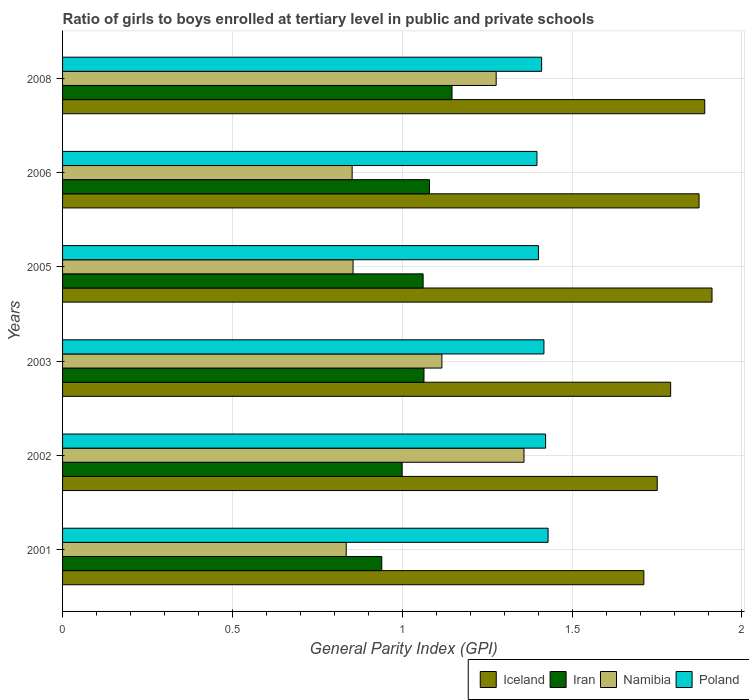How many bars are there on the 2nd tick from the top?
Provide a succinct answer. 4. In how many cases, is the number of bars for a given year not equal to the number of legend labels?
Make the answer very short. 0. What is the general parity index in Iceland in 2002?
Make the answer very short. 1.75. Across all years, what is the maximum general parity index in Poland?
Offer a terse response. 1.43. Across all years, what is the minimum general parity index in Poland?
Offer a very short reply. 1.4. What is the total general parity index in Iran in the graph?
Your answer should be compact. 6.29. What is the difference between the general parity index in Iceland in 2003 and that in 2005?
Your answer should be compact. -0.12. What is the difference between the general parity index in Poland in 2005 and the general parity index in Iceland in 2008?
Offer a very short reply. -0.49. What is the average general parity index in Iran per year?
Offer a very short reply. 1.05. In the year 2003, what is the difference between the general parity index in Iceland and general parity index in Poland?
Give a very brief answer. 0.37. In how many years, is the general parity index in Iceland greater than 1.5 ?
Your response must be concise. 6. What is the ratio of the general parity index in Iceland in 2001 to that in 2006?
Offer a very short reply. 0.91. Is the difference between the general parity index in Iceland in 2005 and 2006 greater than the difference between the general parity index in Poland in 2005 and 2006?
Your response must be concise. Yes. What is the difference between the highest and the second highest general parity index in Iceland?
Offer a very short reply. 0.02. What is the difference between the highest and the lowest general parity index in Poland?
Your response must be concise. 0.03. In how many years, is the general parity index in Iceland greater than the average general parity index in Iceland taken over all years?
Keep it short and to the point. 3. Is the sum of the general parity index in Iran in 2002 and 2005 greater than the maximum general parity index in Iceland across all years?
Provide a succinct answer. Yes. What does the 2nd bar from the top in 2001 represents?
Keep it short and to the point. Namibia. What does the 3rd bar from the bottom in 2002 represents?
Provide a succinct answer. Namibia. Is it the case that in every year, the sum of the general parity index in Iceland and general parity index in Namibia is greater than the general parity index in Poland?
Offer a very short reply. Yes. Are all the bars in the graph horizontal?
Give a very brief answer. Yes. How many years are there in the graph?
Your answer should be very brief. 6. What is the difference between two consecutive major ticks on the X-axis?
Provide a short and direct response. 0.5. Are the values on the major ticks of X-axis written in scientific E-notation?
Provide a succinct answer. No. Does the graph contain grids?
Ensure brevity in your answer.  Yes. What is the title of the graph?
Offer a very short reply. Ratio of girls to boys enrolled at tertiary level in public and private schools. Does "Sint Maarten (Dutch part)" appear as one of the legend labels in the graph?
Offer a very short reply. No. What is the label or title of the X-axis?
Your answer should be very brief. General Parity Index (GPI). What is the label or title of the Y-axis?
Keep it short and to the point. Years. What is the General Parity Index (GPI) in Iceland in 2001?
Offer a terse response. 1.71. What is the General Parity Index (GPI) in Iran in 2001?
Your response must be concise. 0.94. What is the General Parity Index (GPI) of Namibia in 2001?
Ensure brevity in your answer.  0.83. What is the General Parity Index (GPI) in Poland in 2001?
Ensure brevity in your answer.  1.43. What is the General Parity Index (GPI) of Iceland in 2002?
Ensure brevity in your answer.  1.75. What is the General Parity Index (GPI) of Iran in 2002?
Offer a terse response. 1. What is the General Parity Index (GPI) of Namibia in 2002?
Your answer should be very brief. 1.36. What is the General Parity Index (GPI) in Poland in 2002?
Give a very brief answer. 1.42. What is the General Parity Index (GPI) in Iceland in 2003?
Your answer should be compact. 1.79. What is the General Parity Index (GPI) of Iran in 2003?
Your answer should be very brief. 1.06. What is the General Parity Index (GPI) of Namibia in 2003?
Ensure brevity in your answer.  1.12. What is the General Parity Index (GPI) in Poland in 2003?
Provide a succinct answer. 1.42. What is the General Parity Index (GPI) in Iceland in 2005?
Make the answer very short. 1.91. What is the General Parity Index (GPI) in Iran in 2005?
Keep it short and to the point. 1.06. What is the General Parity Index (GPI) of Namibia in 2005?
Give a very brief answer. 0.86. What is the General Parity Index (GPI) of Poland in 2005?
Offer a terse response. 1.4. What is the General Parity Index (GPI) of Iceland in 2006?
Offer a terse response. 1.87. What is the General Parity Index (GPI) in Iran in 2006?
Provide a succinct answer. 1.08. What is the General Parity Index (GPI) in Namibia in 2006?
Make the answer very short. 0.85. What is the General Parity Index (GPI) of Poland in 2006?
Offer a very short reply. 1.4. What is the General Parity Index (GPI) in Iceland in 2008?
Ensure brevity in your answer.  1.89. What is the General Parity Index (GPI) of Iran in 2008?
Your answer should be compact. 1.15. What is the General Parity Index (GPI) of Namibia in 2008?
Provide a succinct answer. 1.28. What is the General Parity Index (GPI) of Poland in 2008?
Provide a short and direct response. 1.41. Across all years, what is the maximum General Parity Index (GPI) of Iceland?
Offer a terse response. 1.91. Across all years, what is the maximum General Parity Index (GPI) in Iran?
Give a very brief answer. 1.15. Across all years, what is the maximum General Parity Index (GPI) of Namibia?
Give a very brief answer. 1.36. Across all years, what is the maximum General Parity Index (GPI) in Poland?
Your answer should be compact. 1.43. Across all years, what is the minimum General Parity Index (GPI) in Iceland?
Keep it short and to the point. 1.71. Across all years, what is the minimum General Parity Index (GPI) in Iran?
Your answer should be compact. 0.94. Across all years, what is the minimum General Parity Index (GPI) in Namibia?
Keep it short and to the point. 0.83. Across all years, what is the minimum General Parity Index (GPI) in Poland?
Keep it short and to the point. 1.4. What is the total General Parity Index (GPI) in Iceland in the graph?
Ensure brevity in your answer.  10.93. What is the total General Parity Index (GPI) of Iran in the graph?
Your answer should be compact. 6.29. What is the total General Parity Index (GPI) in Namibia in the graph?
Keep it short and to the point. 6.29. What is the total General Parity Index (GPI) of Poland in the graph?
Your answer should be very brief. 8.48. What is the difference between the General Parity Index (GPI) of Iceland in 2001 and that in 2002?
Give a very brief answer. -0.04. What is the difference between the General Parity Index (GPI) of Iran in 2001 and that in 2002?
Provide a succinct answer. -0.06. What is the difference between the General Parity Index (GPI) in Namibia in 2001 and that in 2002?
Your response must be concise. -0.52. What is the difference between the General Parity Index (GPI) in Poland in 2001 and that in 2002?
Ensure brevity in your answer.  0.01. What is the difference between the General Parity Index (GPI) of Iceland in 2001 and that in 2003?
Make the answer very short. -0.08. What is the difference between the General Parity Index (GPI) in Iran in 2001 and that in 2003?
Provide a short and direct response. -0.12. What is the difference between the General Parity Index (GPI) of Namibia in 2001 and that in 2003?
Offer a terse response. -0.28. What is the difference between the General Parity Index (GPI) in Poland in 2001 and that in 2003?
Your answer should be very brief. 0.01. What is the difference between the General Parity Index (GPI) in Iceland in 2001 and that in 2005?
Offer a very short reply. -0.2. What is the difference between the General Parity Index (GPI) of Iran in 2001 and that in 2005?
Your answer should be compact. -0.12. What is the difference between the General Parity Index (GPI) of Namibia in 2001 and that in 2005?
Your response must be concise. -0.02. What is the difference between the General Parity Index (GPI) in Poland in 2001 and that in 2005?
Your answer should be very brief. 0.03. What is the difference between the General Parity Index (GPI) of Iceland in 2001 and that in 2006?
Ensure brevity in your answer.  -0.16. What is the difference between the General Parity Index (GPI) of Iran in 2001 and that in 2006?
Your answer should be very brief. -0.14. What is the difference between the General Parity Index (GPI) in Namibia in 2001 and that in 2006?
Make the answer very short. -0.02. What is the difference between the General Parity Index (GPI) in Poland in 2001 and that in 2006?
Your response must be concise. 0.03. What is the difference between the General Parity Index (GPI) in Iceland in 2001 and that in 2008?
Offer a very short reply. -0.18. What is the difference between the General Parity Index (GPI) in Iran in 2001 and that in 2008?
Provide a succinct answer. -0.21. What is the difference between the General Parity Index (GPI) in Namibia in 2001 and that in 2008?
Provide a succinct answer. -0.44. What is the difference between the General Parity Index (GPI) in Poland in 2001 and that in 2008?
Keep it short and to the point. 0.02. What is the difference between the General Parity Index (GPI) in Iceland in 2002 and that in 2003?
Keep it short and to the point. -0.04. What is the difference between the General Parity Index (GPI) in Iran in 2002 and that in 2003?
Keep it short and to the point. -0.06. What is the difference between the General Parity Index (GPI) in Namibia in 2002 and that in 2003?
Make the answer very short. 0.24. What is the difference between the General Parity Index (GPI) in Poland in 2002 and that in 2003?
Offer a very short reply. 0. What is the difference between the General Parity Index (GPI) in Iceland in 2002 and that in 2005?
Offer a terse response. -0.16. What is the difference between the General Parity Index (GPI) in Iran in 2002 and that in 2005?
Keep it short and to the point. -0.06. What is the difference between the General Parity Index (GPI) in Namibia in 2002 and that in 2005?
Offer a very short reply. 0.5. What is the difference between the General Parity Index (GPI) of Poland in 2002 and that in 2005?
Your answer should be very brief. 0.02. What is the difference between the General Parity Index (GPI) of Iceland in 2002 and that in 2006?
Provide a succinct answer. -0.12. What is the difference between the General Parity Index (GPI) of Iran in 2002 and that in 2006?
Keep it short and to the point. -0.08. What is the difference between the General Parity Index (GPI) of Namibia in 2002 and that in 2006?
Give a very brief answer. 0.51. What is the difference between the General Parity Index (GPI) in Poland in 2002 and that in 2006?
Your response must be concise. 0.03. What is the difference between the General Parity Index (GPI) of Iceland in 2002 and that in 2008?
Ensure brevity in your answer.  -0.14. What is the difference between the General Parity Index (GPI) of Iran in 2002 and that in 2008?
Make the answer very short. -0.15. What is the difference between the General Parity Index (GPI) in Namibia in 2002 and that in 2008?
Keep it short and to the point. 0.08. What is the difference between the General Parity Index (GPI) of Poland in 2002 and that in 2008?
Offer a very short reply. 0.01. What is the difference between the General Parity Index (GPI) in Iceland in 2003 and that in 2005?
Make the answer very short. -0.12. What is the difference between the General Parity Index (GPI) of Iran in 2003 and that in 2005?
Your response must be concise. 0. What is the difference between the General Parity Index (GPI) in Namibia in 2003 and that in 2005?
Your answer should be very brief. 0.26. What is the difference between the General Parity Index (GPI) of Poland in 2003 and that in 2005?
Offer a very short reply. 0.02. What is the difference between the General Parity Index (GPI) of Iceland in 2003 and that in 2006?
Your answer should be very brief. -0.08. What is the difference between the General Parity Index (GPI) in Iran in 2003 and that in 2006?
Provide a succinct answer. -0.02. What is the difference between the General Parity Index (GPI) in Namibia in 2003 and that in 2006?
Give a very brief answer. 0.26. What is the difference between the General Parity Index (GPI) of Poland in 2003 and that in 2006?
Provide a short and direct response. 0.02. What is the difference between the General Parity Index (GPI) of Iceland in 2003 and that in 2008?
Your answer should be compact. -0.1. What is the difference between the General Parity Index (GPI) in Iran in 2003 and that in 2008?
Ensure brevity in your answer.  -0.08. What is the difference between the General Parity Index (GPI) in Namibia in 2003 and that in 2008?
Provide a short and direct response. -0.16. What is the difference between the General Parity Index (GPI) in Poland in 2003 and that in 2008?
Make the answer very short. 0.01. What is the difference between the General Parity Index (GPI) in Iceland in 2005 and that in 2006?
Provide a short and direct response. 0.04. What is the difference between the General Parity Index (GPI) in Iran in 2005 and that in 2006?
Offer a terse response. -0.02. What is the difference between the General Parity Index (GPI) of Namibia in 2005 and that in 2006?
Keep it short and to the point. 0. What is the difference between the General Parity Index (GPI) of Poland in 2005 and that in 2006?
Offer a very short reply. 0. What is the difference between the General Parity Index (GPI) of Iceland in 2005 and that in 2008?
Offer a very short reply. 0.02. What is the difference between the General Parity Index (GPI) of Iran in 2005 and that in 2008?
Make the answer very short. -0.09. What is the difference between the General Parity Index (GPI) in Namibia in 2005 and that in 2008?
Provide a succinct answer. -0.42. What is the difference between the General Parity Index (GPI) in Poland in 2005 and that in 2008?
Offer a very short reply. -0.01. What is the difference between the General Parity Index (GPI) of Iceland in 2006 and that in 2008?
Offer a terse response. -0.02. What is the difference between the General Parity Index (GPI) in Iran in 2006 and that in 2008?
Offer a terse response. -0.07. What is the difference between the General Parity Index (GPI) in Namibia in 2006 and that in 2008?
Provide a succinct answer. -0.42. What is the difference between the General Parity Index (GPI) of Poland in 2006 and that in 2008?
Your answer should be compact. -0.01. What is the difference between the General Parity Index (GPI) of Iceland in 2001 and the General Parity Index (GPI) of Iran in 2002?
Provide a succinct answer. 0.71. What is the difference between the General Parity Index (GPI) of Iceland in 2001 and the General Parity Index (GPI) of Namibia in 2002?
Give a very brief answer. 0.35. What is the difference between the General Parity Index (GPI) in Iceland in 2001 and the General Parity Index (GPI) in Poland in 2002?
Your answer should be very brief. 0.29. What is the difference between the General Parity Index (GPI) of Iran in 2001 and the General Parity Index (GPI) of Namibia in 2002?
Make the answer very short. -0.42. What is the difference between the General Parity Index (GPI) of Iran in 2001 and the General Parity Index (GPI) of Poland in 2002?
Your response must be concise. -0.48. What is the difference between the General Parity Index (GPI) of Namibia in 2001 and the General Parity Index (GPI) of Poland in 2002?
Provide a succinct answer. -0.59. What is the difference between the General Parity Index (GPI) of Iceland in 2001 and the General Parity Index (GPI) of Iran in 2003?
Make the answer very short. 0.65. What is the difference between the General Parity Index (GPI) of Iceland in 2001 and the General Parity Index (GPI) of Namibia in 2003?
Provide a succinct answer. 0.59. What is the difference between the General Parity Index (GPI) in Iceland in 2001 and the General Parity Index (GPI) in Poland in 2003?
Your answer should be very brief. 0.29. What is the difference between the General Parity Index (GPI) in Iran in 2001 and the General Parity Index (GPI) in Namibia in 2003?
Make the answer very short. -0.18. What is the difference between the General Parity Index (GPI) of Iran in 2001 and the General Parity Index (GPI) of Poland in 2003?
Offer a terse response. -0.48. What is the difference between the General Parity Index (GPI) of Namibia in 2001 and the General Parity Index (GPI) of Poland in 2003?
Your answer should be compact. -0.58. What is the difference between the General Parity Index (GPI) in Iceland in 2001 and the General Parity Index (GPI) in Iran in 2005?
Provide a succinct answer. 0.65. What is the difference between the General Parity Index (GPI) of Iceland in 2001 and the General Parity Index (GPI) of Namibia in 2005?
Ensure brevity in your answer.  0.86. What is the difference between the General Parity Index (GPI) of Iceland in 2001 and the General Parity Index (GPI) of Poland in 2005?
Keep it short and to the point. 0.31. What is the difference between the General Parity Index (GPI) of Iran in 2001 and the General Parity Index (GPI) of Namibia in 2005?
Provide a short and direct response. 0.08. What is the difference between the General Parity Index (GPI) of Iran in 2001 and the General Parity Index (GPI) of Poland in 2005?
Provide a succinct answer. -0.46. What is the difference between the General Parity Index (GPI) of Namibia in 2001 and the General Parity Index (GPI) of Poland in 2005?
Offer a terse response. -0.57. What is the difference between the General Parity Index (GPI) in Iceland in 2001 and the General Parity Index (GPI) in Iran in 2006?
Offer a very short reply. 0.63. What is the difference between the General Parity Index (GPI) of Iceland in 2001 and the General Parity Index (GPI) of Namibia in 2006?
Keep it short and to the point. 0.86. What is the difference between the General Parity Index (GPI) of Iceland in 2001 and the General Parity Index (GPI) of Poland in 2006?
Your response must be concise. 0.31. What is the difference between the General Parity Index (GPI) in Iran in 2001 and the General Parity Index (GPI) in Namibia in 2006?
Provide a succinct answer. 0.09. What is the difference between the General Parity Index (GPI) of Iran in 2001 and the General Parity Index (GPI) of Poland in 2006?
Your answer should be very brief. -0.46. What is the difference between the General Parity Index (GPI) of Namibia in 2001 and the General Parity Index (GPI) of Poland in 2006?
Offer a very short reply. -0.56. What is the difference between the General Parity Index (GPI) of Iceland in 2001 and the General Parity Index (GPI) of Iran in 2008?
Provide a succinct answer. 0.56. What is the difference between the General Parity Index (GPI) of Iceland in 2001 and the General Parity Index (GPI) of Namibia in 2008?
Ensure brevity in your answer.  0.43. What is the difference between the General Parity Index (GPI) in Iceland in 2001 and the General Parity Index (GPI) in Poland in 2008?
Your answer should be compact. 0.3. What is the difference between the General Parity Index (GPI) in Iran in 2001 and the General Parity Index (GPI) in Namibia in 2008?
Provide a short and direct response. -0.34. What is the difference between the General Parity Index (GPI) in Iran in 2001 and the General Parity Index (GPI) in Poland in 2008?
Keep it short and to the point. -0.47. What is the difference between the General Parity Index (GPI) of Namibia in 2001 and the General Parity Index (GPI) of Poland in 2008?
Your response must be concise. -0.58. What is the difference between the General Parity Index (GPI) in Iceland in 2002 and the General Parity Index (GPI) in Iran in 2003?
Give a very brief answer. 0.69. What is the difference between the General Parity Index (GPI) of Iceland in 2002 and the General Parity Index (GPI) of Namibia in 2003?
Provide a succinct answer. 0.63. What is the difference between the General Parity Index (GPI) in Iceland in 2002 and the General Parity Index (GPI) in Poland in 2003?
Give a very brief answer. 0.33. What is the difference between the General Parity Index (GPI) of Iran in 2002 and the General Parity Index (GPI) of Namibia in 2003?
Offer a very short reply. -0.12. What is the difference between the General Parity Index (GPI) of Iran in 2002 and the General Parity Index (GPI) of Poland in 2003?
Give a very brief answer. -0.42. What is the difference between the General Parity Index (GPI) in Namibia in 2002 and the General Parity Index (GPI) in Poland in 2003?
Your answer should be very brief. -0.06. What is the difference between the General Parity Index (GPI) in Iceland in 2002 and the General Parity Index (GPI) in Iran in 2005?
Offer a very short reply. 0.69. What is the difference between the General Parity Index (GPI) of Iceland in 2002 and the General Parity Index (GPI) of Namibia in 2005?
Keep it short and to the point. 0.9. What is the difference between the General Parity Index (GPI) in Iceland in 2002 and the General Parity Index (GPI) in Poland in 2005?
Offer a terse response. 0.35. What is the difference between the General Parity Index (GPI) of Iran in 2002 and the General Parity Index (GPI) of Namibia in 2005?
Offer a very short reply. 0.14. What is the difference between the General Parity Index (GPI) of Iran in 2002 and the General Parity Index (GPI) of Poland in 2005?
Give a very brief answer. -0.4. What is the difference between the General Parity Index (GPI) of Namibia in 2002 and the General Parity Index (GPI) of Poland in 2005?
Ensure brevity in your answer.  -0.04. What is the difference between the General Parity Index (GPI) in Iceland in 2002 and the General Parity Index (GPI) in Iran in 2006?
Your answer should be compact. 0.67. What is the difference between the General Parity Index (GPI) in Iceland in 2002 and the General Parity Index (GPI) in Namibia in 2006?
Offer a very short reply. 0.9. What is the difference between the General Parity Index (GPI) in Iceland in 2002 and the General Parity Index (GPI) in Poland in 2006?
Make the answer very short. 0.35. What is the difference between the General Parity Index (GPI) in Iran in 2002 and the General Parity Index (GPI) in Namibia in 2006?
Offer a very short reply. 0.15. What is the difference between the General Parity Index (GPI) in Iran in 2002 and the General Parity Index (GPI) in Poland in 2006?
Your answer should be compact. -0.4. What is the difference between the General Parity Index (GPI) of Namibia in 2002 and the General Parity Index (GPI) of Poland in 2006?
Make the answer very short. -0.04. What is the difference between the General Parity Index (GPI) in Iceland in 2002 and the General Parity Index (GPI) in Iran in 2008?
Offer a terse response. 0.6. What is the difference between the General Parity Index (GPI) in Iceland in 2002 and the General Parity Index (GPI) in Namibia in 2008?
Your answer should be compact. 0.47. What is the difference between the General Parity Index (GPI) of Iceland in 2002 and the General Parity Index (GPI) of Poland in 2008?
Provide a short and direct response. 0.34. What is the difference between the General Parity Index (GPI) in Iran in 2002 and the General Parity Index (GPI) in Namibia in 2008?
Make the answer very short. -0.28. What is the difference between the General Parity Index (GPI) of Iran in 2002 and the General Parity Index (GPI) of Poland in 2008?
Give a very brief answer. -0.41. What is the difference between the General Parity Index (GPI) of Namibia in 2002 and the General Parity Index (GPI) of Poland in 2008?
Give a very brief answer. -0.05. What is the difference between the General Parity Index (GPI) of Iceland in 2003 and the General Parity Index (GPI) of Iran in 2005?
Give a very brief answer. 0.73. What is the difference between the General Parity Index (GPI) in Iceland in 2003 and the General Parity Index (GPI) in Namibia in 2005?
Offer a terse response. 0.93. What is the difference between the General Parity Index (GPI) in Iceland in 2003 and the General Parity Index (GPI) in Poland in 2005?
Your response must be concise. 0.39. What is the difference between the General Parity Index (GPI) in Iran in 2003 and the General Parity Index (GPI) in Namibia in 2005?
Make the answer very short. 0.21. What is the difference between the General Parity Index (GPI) in Iran in 2003 and the General Parity Index (GPI) in Poland in 2005?
Make the answer very short. -0.34. What is the difference between the General Parity Index (GPI) of Namibia in 2003 and the General Parity Index (GPI) of Poland in 2005?
Your answer should be compact. -0.28. What is the difference between the General Parity Index (GPI) in Iceland in 2003 and the General Parity Index (GPI) in Iran in 2006?
Your answer should be very brief. 0.71. What is the difference between the General Parity Index (GPI) of Iceland in 2003 and the General Parity Index (GPI) of Namibia in 2006?
Offer a very short reply. 0.94. What is the difference between the General Parity Index (GPI) of Iceland in 2003 and the General Parity Index (GPI) of Poland in 2006?
Your answer should be very brief. 0.39. What is the difference between the General Parity Index (GPI) in Iran in 2003 and the General Parity Index (GPI) in Namibia in 2006?
Offer a terse response. 0.21. What is the difference between the General Parity Index (GPI) of Iran in 2003 and the General Parity Index (GPI) of Poland in 2006?
Give a very brief answer. -0.33. What is the difference between the General Parity Index (GPI) in Namibia in 2003 and the General Parity Index (GPI) in Poland in 2006?
Offer a terse response. -0.28. What is the difference between the General Parity Index (GPI) in Iceland in 2003 and the General Parity Index (GPI) in Iran in 2008?
Make the answer very short. 0.64. What is the difference between the General Parity Index (GPI) of Iceland in 2003 and the General Parity Index (GPI) of Namibia in 2008?
Offer a terse response. 0.51. What is the difference between the General Parity Index (GPI) in Iceland in 2003 and the General Parity Index (GPI) in Poland in 2008?
Offer a terse response. 0.38. What is the difference between the General Parity Index (GPI) in Iran in 2003 and the General Parity Index (GPI) in Namibia in 2008?
Provide a succinct answer. -0.21. What is the difference between the General Parity Index (GPI) in Iran in 2003 and the General Parity Index (GPI) in Poland in 2008?
Offer a terse response. -0.35. What is the difference between the General Parity Index (GPI) in Namibia in 2003 and the General Parity Index (GPI) in Poland in 2008?
Your answer should be compact. -0.29. What is the difference between the General Parity Index (GPI) in Iceland in 2005 and the General Parity Index (GPI) in Iran in 2006?
Ensure brevity in your answer.  0.83. What is the difference between the General Parity Index (GPI) of Iceland in 2005 and the General Parity Index (GPI) of Namibia in 2006?
Keep it short and to the point. 1.06. What is the difference between the General Parity Index (GPI) of Iceland in 2005 and the General Parity Index (GPI) of Poland in 2006?
Offer a very short reply. 0.52. What is the difference between the General Parity Index (GPI) in Iran in 2005 and the General Parity Index (GPI) in Namibia in 2006?
Offer a terse response. 0.21. What is the difference between the General Parity Index (GPI) in Iran in 2005 and the General Parity Index (GPI) in Poland in 2006?
Offer a terse response. -0.34. What is the difference between the General Parity Index (GPI) of Namibia in 2005 and the General Parity Index (GPI) of Poland in 2006?
Ensure brevity in your answer.  -0.54. What is the difference between the General Parity Index (GPI) in Iceland in 2005 and the General Parity Index (GPI) in Iran in 2008?
Offer a very short reply. 0.77. What is the difference between the General Parity Index (GPI) in Iceland in 2005 and the General Parity Index (GPI) in Namibia in 2008?
Provide a succinct answer. 0.64. What is the difference between the General Parity Index (GPI) in Iceland in 2005 and the General Parity Index (GPI) in Poland in 2008?
Offer a terse response. 0.5. What is the difference between the General Parity Index (GPI) in Iran in 2005 and the General Parity Index (GPI) in Namibia in 2008?
Keep it short and to the point. -0.21. What is the difference between the General Parity Index (GPI) of Iran in 2005 and the General Parity Index (GPI) of Poland in 2008?
Your answer should be compact. -0.35. What is the difference between the General Parity Index (GPI) of Namibia in 2005 and the General Parity Index (GPI) of Poland in 2008?
Your answer should be compact. -0.56. What is the difference between the General Parity Index (GPI) of Iceland in 2006 and the General Parity Index (GPI) of Iran in 2008?
Offer a very short reply. 0.73. What is the difference between the General Parity Index (GPI) of Iceland in 2006 and the General Parity Index (GPI) of Namibia in 2008?
Ensure brevity in your answer.  0.6. What is the difference between the General Parity Index (GPI) of Iceland in 2006 and the General Parity Index (GPI) of Poland in 2008?
Ensure brevity in your answer.  0.46. What is the difference between the General Parity Index (GPI) of Iran in 2006 and the General Parity Index (GPI) of Namibia in 2008?
Offer a very short reply. -0.2. What is the difference between the General Parity Index (GPI) of Iran in 2006 and the General Parity Index (GPI) of Poland in 2008?
Your answer should be compact. -0.33. What is the difference between the General Parity Index (GPI) of Namibia in 2006 and the General Parity Index (GPI) of Poland in 2008?
Ensure brevity in your answer.  -0.56. What is the average General Parity Index (GPI) in Iceland per year?
Your answer should be compact. 1.82. What is the average General Parity Index (GPI) in Iran per year?
Your answer should be compact. 1.05. What is the average General Parity Index (GPI) of Namibia per year?
Provide a succinct answer. 1.05. What is the average General Parity Index (GPI) in Poland per year?
Provide a short and direct response. 1.41. In the year 2001, what is the difference between the General Parity Index (GPI) of Iceland and General Parity Index (GPI) of Iran?
Your answer should be compact. 0.77. In the year 2001, what is the difference between the General Parity Index (GPI) of Iceland and General Parity Index (GPI) of Namibia?
Offer a very short reply. 0.88. In the year 2001, what is the difference between the General Parity Index (GPI) in Iceland and General Parity Index (GPI) in Poland?
Ensure brevity in your answer.  0.28. In the year 2001, what is the difference between the General Parity Index (GPI) of Iran and General Parity Index (GPI) of Namibia?
Your answer should be compact. 0.1. In the year 2001, what is the difference between the General Parity Index (GPI) of Iran and General Parity Index (GPI) of Poland?
Offer a very short reply. -0.49. In the year 2001, what is the difference between the General Parity Index (GPI) of Namibia and General Parity Index (GPI) of Poland?
Offer a very short reply. -0.59. In the year 2002, what is the difference between the General Parity Index (GPI) of Iceland and General Parity Index (GPI) of Iran?
Provide a short and direct response. 0.75. In the year 2002, what is the difference between the General Parity Index (GPI) in Iceland and General Parity Index (GPI) in Namibia?
Offer a terse response. 0.39. In the year 2002, what is the difference between the General Parity Index (GPI) in Iceland and General Parity Index (GPI) in Poland?
Offer a very short reply. 0.33. In the year 2002, what is the difference between the General Parity Index (GPI) in Iran and General Parity Index (GPI) in Namibia?
Your answer should be very brief. -0.36. In the year 2002, what is the difference between the General Parity Index (GPI) in Iran and General Parity Index (GPI) in Poland?
Give a very brief answer. -0.42. In the year 2002, what is the difference between the General Parity Index (GPI) of Namibia and General Parity Index (GPI) of Poland?
Make the answer very short. -0.06. In the year 2003, what is the difference between the General Parity Index (GPI) in Iceland and General Parity Index (GPI) in Iran?
Your answer should be compact. 0.73. In the year 2003, what is the difference between the General Parity Index (GPI) of Iceland and General Parity Index (GPI) of Namibia?
Make the answer very short. 0.67. In the year 2003, what is the difference between the General Parity Index (GPI) of Iceland and General Parity Index (GPI) of Poland?
Your answer should be compact. 0.37. In the year 2003, what is the difference between the General Parity Index (GPI) in Iran and General Parity Index (GPI) in Namibia?
Offer a very short reply. -0.05. In the year 2003, what is the difference between the General Parity Index (GPI) in Iran and General Parity Index (GPI) in Poland?
Make the answer very short. -0.35. In the year 2003, what is the difference between the General Parity Index (GPI) in Namibia and General Parity Index (GPI) in Poland?
Offer a very short reply. -0.3. In the year 2005, what is the difference between the General Parity Index (GPI) of Iceland and General Parity Index (GPI) of Iran?
Keep it short and to the point. 0.85. In the year 2005, what is the difference between the General Parity Index (GPI) in Iceland and General Parity Index (GPI) in Namibia?
Your answer should be compact. 1.06. In the year 2005, what is the difference between the General Parity Index (GPI) of Iceland and General Parity Index (GPI) of Poland?
Provide a succinct answer. 0.51. In the year 2005, what is the difference between the General Parity Index (GPI) of Iran and General Parity Index (GPI) of Namibia?
Ensure brevity in your answer.  0.21. In the year 2005, what is the difference between the General Parity Index (GPI) of Iran and General Parity Index (GPI) of Poland?
Make the answer very short. -0.34. In the year 2005, what is the difference between the General Parity Index (GPI) in Namibia and General Parity Index (GPI) in Poland?
Provide a succinct answer. -0.55. In the year 2006, what is the difference between the General Parity Index (GPI) of Iceland and General Parity Index (GPI) of Iran?
Your answer should be compact. 0.79. In the year 2006, what is the difference between the General Parity Index (GPI) of Iceland and General Parity Index (GPI) of Namibia?
Your answer should be very brief. 1.02. In the year 2006, what is the difference between the General Parity Index (GPI) in Iceland and General Parity Index (GPI) in Poland?
Provide a succinct answer. 0.48. In the year 2006, what is the difference between the General Parity Index (GPI) of Iran and General Parity Index (GPI) of Namibia?
Your answer should be very brief. 0.23. In the year 2006, what is the difference between the General Parity Index (GPI) of Iran and General Parity Index (GPI) of Poland?
Provide a short and direct response. -0.32. In the year 2006, what is the difference between the General Parity Index (GPI) in Namibia and General Parity Index (GPI) in Poland?
Your answer should be compact. -0.54. In the year 2008, what is the difference between the General Parity Index (GPI) of Iceland and General Parity Index (GPI) of Iran?
Make the answer very short. 0.74. In the year 2008, what is the difference between the General Parity Index (GPI) in Iceland and General Parity Index (GPI) in Namibia?
Your response must be concise. 0.61. In the year 2008, what is the difference between the General Parity Index (GPI) in Iceland and General Parity Index (GPI) in Poland?
Provide a succinct answer. 0.48. In the year 2008, what is the difference between the General Parity Index (GPI) of Iran and General Parity Index (GPI) of Namibia?
Ensure brevity in your answer.  -0.13. In the year 2008, what is the difference between the General Parity Index (GPI) of Iran and General Parity Index (GPI) of Poland?
Provide a succinct answer. -0.26. In the year 2008, what is the difference between the General Parity Index (GPI) in Namibia and General Parity Index (GPI) in Poland?
Offer a terse response. -0.13. What is the ratio of the General Parity Index (GPI) in Iceland in 2001 to that in 2002?
Offer a terse response. 0.98. What is the ratio of the General Parity Index (GPI) in Namibia in 2001 to that in 2002?
Offer a very short reply. 0.61. What is the ratio of the General Parity Index (GPI) of Poland in 2001 to that in 2002?
Your answer should be very brief. 1.01. What is the ratio of the General Parity Index (GPI) of Iceland in 2001 to that in 2003?
Your response must be concise. 0.96. What is the ratio of the General Parity Index (GPI) of Iran in 2001 to that in 2003?
Offer a terse response. 0.88. What is the ratio of the General Parity Index (GPI) of Namibia in 2001 to that in 2003?
Your answer should be compact. 0.75. What is the ratio of the General Parity Index (GPI) in Poland in 2001 to that in 2003?
Make the answer very short. 1.01. What is the ratio of the General Parity Index (GPI) of Iceland in 2001 to that in 2005?
Make the answer very short. 0.9. What is the ratio of the General Parity Index (GPI) in Iran in 2001 to that in 2005?
Your response must be concise. 0.89. What is the ratio of the General Parity Index (GPI) of Namibia in 2001 to that in 2005?
Keep it short and to the point. 0.98. What is the ratio of the General Parity Index (GPI) in Poland in 2001 to that in 2005?
Give a very brief answer. 1.02. What is the ratio of the General Parity Index (GPI) in Iceland in 2001 to that in 2006?
Provide a succinct answer. 0.91. What is the ratio of the General Parity Index (GPI) of Iran in 2001 to that in 2006?
Your response must be concise. 0.87. What is the ratio of the General Parity Index (GPI) in Namibia in 2001 to that in 2006?
Give a very brief answer. 0.98. What is the ratio of the General Parity Index (GPI) in Poland in 2001 to that in 2006?
Provide a short and direct response. 1.02. What is the ratio of the General Parity Index (GPI) of Iceland in 2001 to that in 2008?
Offer a very short reply. 0.91. What is the ratio of the General Parity Index (GPI) in Iran in 2001 to that in 2008?
Offer a terse response. 0.82. What is the ratio of the General Parity Index (GPI) of Namibia in 2001 to that in 2008?
Your answer should be compact. 0.65. What is the ratio of the General Parity Index (GPI) of Poland in 2001 to that in 2008?
Provide a short and direct response. 1.01. What is the ratio of the General Parity Index (GPI) of Iceland in 2002 to that in 2003?
Provide a short and direct response. 0.98. What is the ratio of the General Parity Index (GPI) of Iran in 2002 to that in 2003?
Provide a succinct answer. 0.94. What is the ratio of the General Parity Index (GPI) in Namibia in 2002 to that in 2003?
Your answer should be compact. 1.22. What is the ratio of the General Parity Index (GPI) in Poland in 2002 to that in 2003?
Your answer should be very brief. 1. What is the ratio of the General Parity Index (GPI) in Iceland in 2002 to that in 2005?
Offer a very short reply. 0.92. What is the ratio of the General Parity Index (GPI) in Iran in 2002 to that in 2005?
Give a very brief answer. 0.94. What is the ratio of the General Parity Index (GPI) of Namibia in 2002 to that in 2005?
Provide a short and direct response. 1.59. What is the ratio of the General Parity Index (GPI) of Poland in 2002 to that in 2005?
Your answer should be very brief. 1.01. What is the ratio of the General Parity Index (GPI) in Iceland in 2002 to that in 2006?
Your answer should be very brief. 0.93. What is the ratio of the General Parity Index (GPI) of Iran in 2002 to that in 2006?
Give a very brief answer. 0.93. What is the ratio of the General Parity Index (GPI) in Namibia in 2002 to that in 2006?
Provide a succinct answer. 1.59. What is the ratio of the General Parity Index (GPI) in Poland in 2002 to that in 2006?
Your answer should be very brief. 1.02. What is the ratio of the General Parity Index (GPI) of Iceland in 2002 to that in 2008?
Provide a succinct answer. 0.93. What is the ratio of the General Parity Index (GPI) in Iran in 2002 to that in 2008?
Provide a short and direct response. 0.87. What is the ratio of the General Parity Index (GPI) of Namibia in 2002 to that in 2008?
Ensure brevity in your answer.  1.06. What is the ratio of the General Parity Index (GPI) in Poland in 2002 to that in 2008?
Keep it short and to the point. 1.01. What is the ratio of the General Parity Index (GPI) in Iceland in 2003 to that in 2005?
Your response must be concise. 0.94. What is the ratio of the General Parity Index (GPI) of Namibia in 2003 to that in 2005?
Your answer should be compact. 1.31. What is the ratio of the General Parity Index (GPI) in Poland in 2003 to that in 2005?
Keep it short and to the point. 1.01. What is the ratio of the General Parity Index (GPI) in Iceland in 2003 to that in 2006?
Your answer should be compact. 0.96. What is the ratio of the General Parity Index (GPI) of Namibia in 2003 to that in 2006?
Your response must be concise. 1.31. What is the ratio of the General Parity Index (GPI) in Poland in 2003 to that in 2006?
Your answer should be compact. 1.01. What is the ratio of the General Parity Index (GPI) of Iceland in 2003 to that in 2008?
Offer a very short reply. 0.95. What is the ratio of the General Parity Index (GPI) of Iran in 2003 to that in 2008?
Make the answer very short. 0.93. What is the ratio of the General Parity Index (GPI) of Namibia in 2003 to that in 2008?
Your answer should be very brief. 0.87. What is the ratio of the General Parity Index (GPI) in Iceland in 2005 to that in 2006?
Your answer should be very brief. 1.02. What is the ratio of the General Parity Index (GPI) of Iran in 2005 to that in 2006?
Your answer should be compact. 0.98. What is the ratio of the General Parity Index (GPI) in Namibia in 2005 to that in 2006?
Make the answer very short. 1. What is the ratio of the General Parity Index (GPI) of Poland in 2005 to that in 2006?
Offer a very short reply. 1. What is the ratio of the General Parity Index (GPI) of Iceland in 2005 to that in 2008?
Keep it short and to the point. 1.01. What is the ratio of the General Parity Index (GPI) of Iran in 2005 to that in 2008?
Keep it short and to the point. 0.93. What is the ratio of the General Parity Index (GPI) in Namibia in 2005 to that in 2008?
Your response must be concise. 0.67. What is the ratio of the General Parity Index (GPI) in Poland in 2005 to that in 2008?
Offer a very short reply. 0.99. What is the ratio of the General Parity Index (GPI) of Iceland in 2006 to that in 2008?
Ensure brevity in your answer.  0.99. What is the ratio of the General Parity Index (GPI) of Iran in 2006 to that in 2008?
Give a very brief answer. 0.94. What is the ratio of the General Parity Index (GPI) of Namibia in 2006 to that in 2008?
Provide a succinct answer. 0.67. What is the ratio of the General Parity Index (GPI) of Poland in 2006 to that in 2008?
Offer a very short reply. 0.99. What is the difference between the highest and the second highest General Parity Index (GPI) of Iceland?
Your answer should be very brief. 0.02. What is the difference between the highest and the second highest General Parity Index (GPI) in Iran?
Your answer should be compact. 0.07. What is the difference between the highest and the second highest General Parity Index (GPI) of Namibia?
Your response must be concise. 0.08. What is the difference between the highest and the second highest General Parity Index (GPI) in Poland?
Keep it short and to the point. 0.01. What is the difference between the highest and the lowest General Parity Index (GPI) in Iceland?
Ensure brevity in your answer.  0.2. What is the difference between the highest and the lowest General Parity Index (GPI) in Iran?
Keep it short and to the point. 0.21. What is the difference between the highest and the lowest General Parity Index (GPI) of Namibia?
Your answer should be compact. 0.52. What is the difference between the highest and the lowest General Parity Index (GPI) of Poland?
Your answer should be compact. 0.03. 